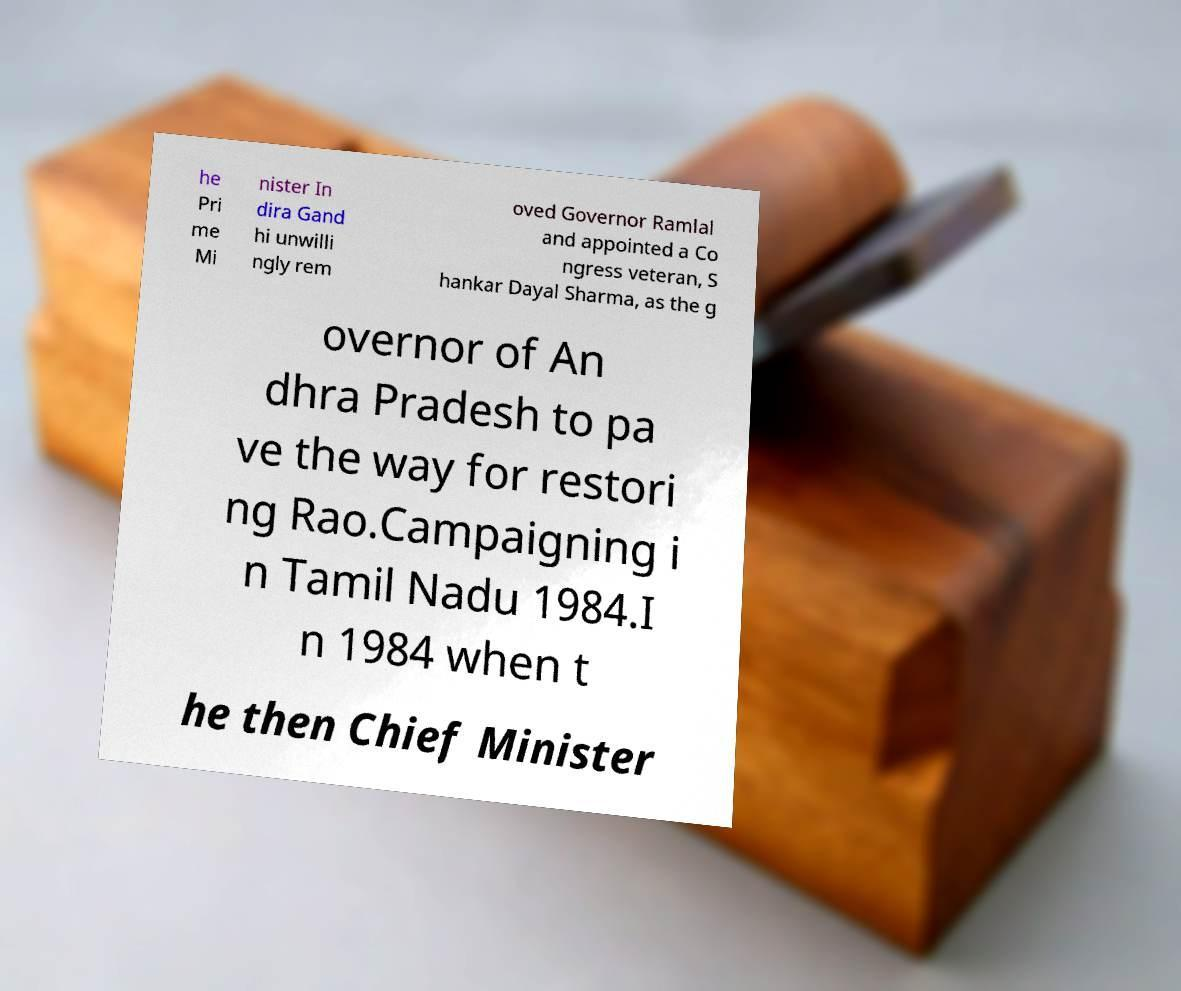What messages or text are displayed in this image? I need them in a readable, typed format. he Pri me Mi nister In dira Gand hi unwilli ngly rem oved Governor Ramlal and appointed a Co ngress veteran, S hankar Dayal Sharma, as the g overnor of An dhra Pradesh to pa ve the way for restori ng Rao.Campaigning i n Tamil Nadu 1984.I n 1984 when t he then Chief Minister 